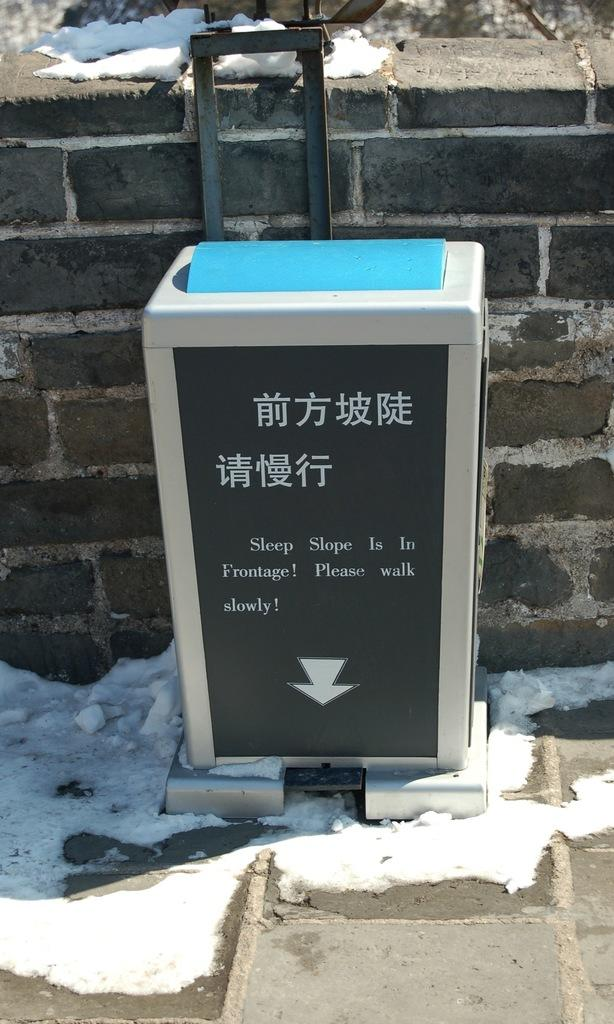Provide a one-sentence caption for the provided image. a box like sign telling you to watch your step on the slope sidewalk. 